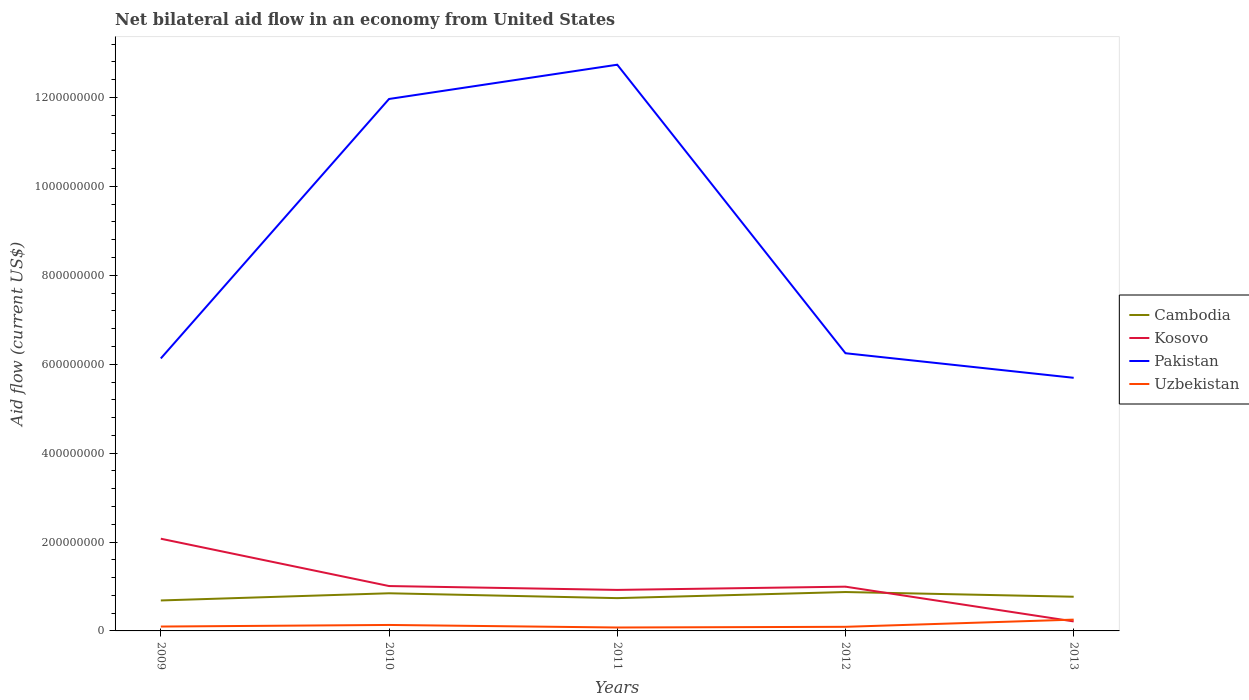Across all years, what is the maximum net bilateral aid flow in Uzbekistan?
Your response must be concise. 7.68e+06. What is the total net bilateral aid flow in Kosovo in the graph?
Make the answer very short. 1.08e+08. What is the difference between the highest and the second highest net bilateral aid flow in Kosovo?
Your answer should be compact. 1.86e+08. Is the net bilateral aid flow in Kosovo strictly greater than the net bilateral aid flow in Pakistan over the years?
Keep it short and to the point. Yes. How many lines are there?
Make the answer very short. 4. How many years are there in the graph?
Provide a short and direct response. 5. What is the difference between two consecutive major ticks on the Y-axis?
Make the answer very short. 2.00e+08. Does the graph contain grids?
Offer a terse response. No. Where does the legend appear in the graph?
Your answer should be compact. Center right. How many legend labels are there?
Make the answer very short. 4. How are the legend labels stacked?
Keep it short and to the point. Vertical. What is the title of the graph?
Ensure brevity in your answer.  Net bilateral aid flow in an economy from United States. What is the label or title of the X-axis?
Provide a short and direct response. Years. What is the Aid flow (current US$) of Cambodia in 2009?
Provide a succinct answer. 6.86e+07. What is the Aid flow (current US$) in Kosovo in 2009?
Ensure brevity in your answer.  2.07e+08. What is the Aid flow (current US$) in Pakistan in 2009?
Keep it short and to the point. 6.13e+08. What is the Aid flow (current US$) in Uzbekistan in 2009?
Provide a succinct answer. 9.85e+06. What is the Aid flow (current US$) in Cambodia in 2010?
Your answer should be compact. 8.47e+07. What is the Aid flow (current US$) of Kosovo in 2010?
Give a very brief answer. 1.01e+08. What is the Aid flow (current US$) of Pakistan in 2010?
Your answer should be very brief. 1.20e+09. What is the Aid flow (current US$) in Uzbekistan in 2010?
Your answer should be very brief. 1.34e+07. What is the Aid flow (current US$) of Cambodia in 2011?
Your answer should be very brief. 7.38e+07. What is the Aid flow (current US$) of Kosovo in 2011?
Your answer should be very brief. 9.23e+07. What is the Aid flow (current US$) in Pakistan in 2011?
Offer a very short reply. 1.27e+09. What is the Aid flow (current US$) in Uzbekistan in 2011?
Your answer should be very brief. 7.68e+06. What is the Aid flow (current US$) of Cambodia in 2012?
Make the answer very short. 8.75e+07. What is the Aid flow (current US$) in Kosovo in 2012?
Offer a very short reply. 9.96e+07. What is the Aid flow (current US$) of Pakistan in 2012?
Offer a very short reply. 6.25e+08. What is the Aid flow (current US$) of Uzbekistan in 2012?
Your response must be concise. 9.25e+06. What is the Aid flow (current US$) of Cambodia in 2013?
Keep it short and to the point. 7.69e+07. What is the Aid flow (current US$) in Kosovo in 2013?
Offer a very short reply. 2.14e+07. What is the Aid flow (current US$) in Pakistan in 2013?
Provide a succinct answer. 5.69e+08. What is the Aid flow (current US$) of Uzbekistan in 2013?
Your response must be concise. 2.54e+07. Across all years, what is the maximum Aid flow (current US$) of Cambodia?
Keep it short and to the point. 8.75e+07. Across all years, what is the maximum Aid flow (current US$) in Kosovo?
Your response must be concise. 2.07e+08. Across all years, what is the maximum Aid flow (current US$) in Pakistan?
Offer a terse response. 1.27e+09. Across all years, what is the maximum Aid flow (current US$) in Uzbekistan?
Keep it short and to the point. 2.54e+07. Across all years, what is the minimum Aid flow (current US$) in Cambodia?
Make the answer very short. 6.86e+07. Across all years, what is the minimum Aid flow (current US$) in Kosovo?
Your answer should be very brief. 2.14e+07. Across all years, what is the minimum Aid flow (current US$) in Pakistan?
Provide a succinct answer. 5.69e+08. Across all years, what is the minimum Aid flow (current US$) in Uzbekistan?
Make the answer very short. 7.68e+06. What is the total Aid flow (current US$) of Cambodia in the graph?
Offer a terse response. 3.91e+08. What is the total Aid flow (current US$) of Kosovo in the graph?
Offer a very short reply. 5.22e+08. What is the total Aid flow (current US$) of Pakistan in the graph?
Your answer should be compact. 4.28e+09. What is the total Aid flow (current US$) of Uzbekistan in the graph?
Your answer should be very brief. 6.56e+07. What is the difference between the Aid flow (current US$) in Cambodia in 2009 and that in 2010?
Offer a terse response. -1.61e+07. What is the difference between the Aid flow (current US$) in Kosovo in 2009 and that in 2010?
Keep it short and to the point. 1.06e+08. What is the difference between the Aid flow (current US$) in Pakistan in 2009 and that in 2010?
Give a very brief answer. -5.84e+08. What is the difference between the Aid flow (current US$) in Uzbekistan in 2009 and that in 2010?
Your response must be concise. -3.59e+06. What is the difference between the Aid flow (current US$) in Cambodia in 2009 and that in 2011?
Offer a terse response. -5.22e+06. What is the difference between the Aid flow (current US$) in Kosovo in 2009 and that in 2011?
Give a very brief answer. 1.15e+08. What is the difference between the Aid flow (current US$) of Pakistan in 2009 and that in 2011?
Give a very brief answer. -6.61e+08. What is the difference between the Aid flow (current US$) of Uzbekistan in 2009 and that in 2011?
Give a very brief answer. 2.17e+06. What is the difference between the Aid flow (current US$) of Cambodia in 2009 and that in 2012?
Offer a terse response. -1.89e+07. What is the difference between the Aid flow (current US$) in Kosovo in 2009 and that in 2012?
Offer a very short reply. 1.08e+08. What is the difference between the Aid flow (current US$) in Pakistan in 2009 and that in 2012?
Your answer should be compact. -1.17e+07. What is the difference between the Aid flow (current US$) in Uzbekistan in 2009 and that in 2012?
Your answer should be compact. 6.00e+05. What is the difference between the Aid flow (current US$) of Cambodia in 2009 and that in 2013?
Your answer should be very brief. -8.36e+06. What is the difference between the Aid flow (current US$) in Kosovo in 2009 and that in 2013?
Your answer should be compact. 1.86e+08. What is the difference between the Aid flow (current US$) in Pakistan in 2009 and that in 2013?
Offer a terse response. 4.36e+07. What is the difference between the Aid flow (current US$) of Uzbekistan in 2009 and that in 2013?
Provide a succinct answer. -1.56e+07. What is the difference between the Aid flow (current US$) in Cambodia in 2010 and that in 2011?
Your answer should be very brief. 1.09e+07. What is the difference between the Aid flow (current US$) in Kosovo in 2010 and that in 2011?
Your answer should be compact. 8.70e+06. What is the difference between the Aid flow (current US$) of Pakistan in 2010 and that in 2011?
Keep it short and to the point. -7.71e+07. What is the difference between the Aid flow (current US$) of Uzbekistan in 2010 and that in 2011?
Provide a succinct answer. 5.76e+06. What is the difference between the Aid flow (current US$) of Cambodia in 2010 and that in 2012?
Your answer should be very brief. -2.78e+06. What is the difference between the Aid flow (current US$) in Kosovo in 2010 and that in 2012?
Keep it short and to the point. 1.42e+06. What is the difference between the Aid flow (current US$) of Pakistan in 2010 and that in 2012?
Your response must be concise. 5.72e+08. What is the difference between the Aid flow (current US$) of Uzbekistan in 2010 and that in 2012?
Your response must be concise. 4.19e+06. What is the difference between the Aid flow (current US$) in Cambodia in 2010 and that in 2013?
Provide a succinct answer. 7.78e+06. What is the difference between the Aid flow (current US$) of Kosovo in 2010 and that in 2013?
Provide a short and direct response. 7.96e+07. What is the difference between the Aid flow (current US$) in Pakistan in 2010 and that in 2013?
Provide a succinct answer. 6.27e+08. What is the difference between the Aid flow (current US$) of Uzbekistan in 2010 and that in 2013?
Offer a very short reply. -1.20e+07. What is the difference between the Aid flow (current US$) in Cambodia in 2011 and that in 2012?
Offer a terse response. -1.37e+07. What is the difference between the Aid flow (current US$) of Kosovo in 2011 and that in 2012?
Your answer should be very brief. -7.28e+06. What is the difference between the Aid flow (current US$) in Pakistan in 2011 and that in 2012?
Make the answer very short. 6.49e+08. What is the difference between the Aid flow (current US$) in Uzbekistan in 2011 and that in 2012?
Your answer should be very brief. -1.57e+06. What is the difference between the Aid flow (current US$) in Cambodia in 2011 and that in 2013?
Offer a terse response. -3.14e+06. What is the difference between the Aid flow (current US$) of Kosovo in 2011 and that in 2013?
Keep it short and to the point. 7.09e+07. What is the difference between the Aid flow (current US$) of Pakistan in 2011 and that in 2013?
Give a very brief answer. 7.04e+08. What is the difference between the Aid flow (current US$) of Uzbekistan in 2011 and that in 2013?
Offer a very short reply. -1.77e+07. What is the difference between the Aid flow (current US$) in Cambodia in 2012 and that in 2013?
Offer a very short reply. 1.06e+07. What is the difference between the Aid flow (current US$) of Kosovo in 2012 and that in 2013?
Your response must be concise. 7.82e+07. What is the difference between the Aid flow (current US$) of Pakistan in 2012 and that in 2013?
Provide a succinct answer. 5.53e+07. What is the difference between the Aid flow (current US$) of Uzbekistan in 2012 and that in 2013?
Give a very brief answer. -1.62e+07. What is the difference between the Aid flow (current US$) in Cambodia in 2009 and the Aid flow (current US$) in Kosovo in 2010?
Your answer should be very brief. -3.24e+07. What is the difference between the Aid flow (current US$) in Cambodia in 2009 and the Aid flow (current US$) in Pakistan in 2010?
Your answer should be very brief. -1.13e+09. What is the difference between the Aid flow (current US$) in Cambodia in 2009 and the Aid flow (current US$) in Uzbekistan in 2010?
Your response must be concise. 5.51e+07. What is the difference between the Aid flow (current US$) of Kosovo in 2009 and the Aid flow (current US$) of Pakistan in 2010?
Keep it short and to the point. -9.89e+08. What is the difference between the Aid flow (current US$) in Kosovo in 2009 and the Aid flow (current US$) in Uzbekistan in 2010?
Offer a terse response. 1.94e+08. What is the difference between the Aid flow (current US$) in Pakistan in 2009 and the Aid flow (current US$) in Uzbekistan in 2010?
Ensure brevity in your answer.  6.00e+08. What is the difference between the Aid flow (current US$) of Cambodia in 2009 and the Aid flow (current US$) of Kosovo in 2011?
Give a very brief answer. -2.37e+07. What is the difference between the Aid flow (current US$) of Cambodia in 2009 and the Aid flow (current US$) of Pakistan in 2011?
Provide a short and direct response. -1.21e+09. What is the difference between the Aid flow (current US$) of Cambodia in 2009 and the Aid flow (current US$) of Uzbekistan in 2011?
Ensure brevity in your answer.  6.09e+07. What is the difference between the Aid flow (current US$) of Kosovo in 2009 and the Aid flow (current US$) of Pakistan in 2011?
Your response must be concise. -1.07e+09. What is the difference between the Aid flow (current US$) in Kosovo in 2009 and the Aid flow (current US$) in Uzbekistan in 2011?
Give a very brief answer. 2.00e+08. What is the difference between the Aid flow (current US$) in Pakistan in 2009 and the Aid flow (current US$) in Uzbekistan in 2011?
Give a very brief answer. 6.05e+08. What is the difference between the Aid flow (current US$) of Cambodia in 2009 and the Aid flow (current US$) of Kosovo in 2012?
Your answer should be very brief. -3.10e+07. What is the difference between the Aid flow (current US$) in Cambodia in 2009 and the Aid flow (current US$) in Pakistan in 2012?
Your answer should be compact. -5.56e+08. What is the difference between the Aid flow (current US$) of Cambodia in 2009 and the Aid flow (current US$) of Uzbekistan in 2012?
Ensure brevity in your answer.  5.93e+07. What is the difference between the Aid flow (current US$) of Kosovo in 2009 and the Aid flow (current US$) of Pakistan in 2012?
Offer a terse response. -4.17e+08. What is the difference between the Aid flow (current US$) of Kosovo in 2009 and the Aid flow (current US$) of Uzbekistan in 2012?
Give a very brief answer. 1.98e+08. What is the difference between the Aid flow (current US$) of Pakistan in 2009 and the Aid flow (current US$) of Uzbekistan in 2012?
Offer a very short reply. 6.04e+08. What is the difference between the Aid flow (current US$) in Cambodia in 2009 and the Aid flow (current US$) in Kosovo in 2013?
Ensure brevity in your answer.  4.72e+07. What is the difference between the Aid flow (current US$) of Cambodia in 2009 and the Aid flow (current US$) of Pakistan in 2013?
Your response must be concise. -5.01e+08. What is the difference between the Aid flow (current US$) of Cambodia in 2009 and the Aid flow (current US$) of Uzbekistan in 2013?
Make the answer very short. 4.31e+07. What is the difference between the Aid flow (current US$) of Kosovo in 2009 and the Aid flow (current US$) of Pakistan in 2013?
Keep it short and to the point. -3.62e+08. What is the difference between the Aid flow (current US$) in Kosovo in 2009 and the Aid flow (current US$) in Uzbekistan in 2013?
Offer a very short reply. 1.82e+08. What is the difference between the Aid flow (current US$) in Pakistan in 2009 and the Aid flow (current US$) in Uzbekistan in 2013?
Your answer should be very brief. 5.88e+08. What is the difference between the Aid flow (current US$) of Cambodia in 2010 and the Aid flow (current US$) of Kosovo in 2011?
Offer a terse response. -7.57e+06. What is the difference between the Aid flow (current US$) in Cambodia in 2010 and the Aid flow (current US$) in Pakistan in 2011?
Keep it short and to the point. -1.19e+09. What is the difference between the Aid flow (current US$) of Cambodia in 2010 and the Aid flow (current US$) of Uzbekistan in 2011?
Your response must be concise. 7.70e+07. What is the difference between the Aid flow (current US$) of Kosovo in 2010 and the Aid flow (current US$) of Pakistan in 2011?
Your response must be concise. -1.17e+09. What is the difference between the Aid flow (current US$) in Kosovo in 2010 and the Aid flow (current US$) in Uzbekistan in 2011?
Make the answer very short. 9.33e+07. What is the difference between the Aid flow (current US$) of Pakistan in 2010 and the Aid flow (current US$) of Uzbekistan in 2011?
Provide a succinct answer. 1.19e+09. What is the difference between the Aid flow (current US$) in Cambodia in 2010 and the Aid flow (current US$) in Kosovo in 2012?
Provide a succinct answer. -1.48e+07. What is the difference between the Aid flow (current US$) in Cambodia in 2010 and the Aid flow (current US$) in Pakistan in 2012?
Keep it short and to the point. -5.40e+08. What is the difference between the Aid flow (current US$) in Cambodia in 2010 and the Aid flow (current US$) in Uzbekistan in 2012?
Offer a terse response. 7.54e+07. What is the difference between the Aid flow (current US$) of Kosovo in 2010 and the Aid flow (current US$) of Pakistan in 2012?
Provide a succinct answer. -5.24e+08. What is the difference between the Aid flow (current US$) of Kosovo in 2010 and the Aid flow (current US$) of Uzbekistan in 2012?
Give a very brief answer. 9.17e+07. What is the difference between the Aid flow (current US$) in Pakistan in 2010 and the Aid flow (current US$) in Uzbekistan in 2012?
Make the answer very short. 1.19e+09. What is the difference between the Aid flow (current US$) of Cambodia in 2010 and the Aid flow (current US$) of Kosovo in 2013?
Make the answer very short. 6.33e+07. What is the difference between the Aid flow (current US$) in Cambodia in 2010 and the Aid flow (current US$) in Pakistan in 2013?
Keep it short and to the point. -4.85e+08. What is the difference between the Aid flow (current US$) in Cambodia in 2010 and the Aid flow (current US$) in Uzbekistan in 2013?
Your answer should be compact. 5.93e+07. What is the difference between the Aid flow (current US$) of Kosovo in 2010 and the Aid flow (current US$) of Pakistan in 2013?
Keep it short and to the point. -4.68e+08. What is the difference between the Aid flow (current US$) of Kosovo in 2010 and the Aid flow (current US$) of Uzbekistan in 2013?
Offer a very short reply. 7.56e+07. What is the difference between the Aid flow (current US$) in Pakistan in 2010 and the Aid flow (current US$) in Uzbekistan in 2013?
Your answer should be compact. 1.17e+09. What is the difference between the Aid flow (current US$) of Cambodia in 2011 and the Aid flow (current US$) of Kosovo in 2012?
Ensure brevity in your answer.  -2.58e+07. What is the difference between the Aid flow (current US$) of Cambodia in 2011 and the Aid flow (current US$) of Pakistan in 2012?
Make the answer very short. -5.51e+08. What is the difference between the Aid flow (current US$) of Cambodia in 2011 and the Aid flow (current US$) of Uzbekistan in 2012?
Your answer should be very brief. 6.45e+07. What is the difference between the Aid flow (current US$) of Kosovo in 2011 and the Aid flow (current US$) of Pakistan in 2012?
Your answer should be compact. -5.32e+08. What is the difference between the Aid flow (current US$) of Kosovo in 2011 and the Aid flow (current US$) of Uzbekistan in 2012?
Provide a succinct answer. 8.30e+07. What is the difference between the Aid flow (current US$) of Pakistan in 2011 and the Aid flow (current US$) of Uzbekistan in 2012?
Your answer should be compact. 1.26e+09. What is the difference between the Aid flow (current US$) in Cambodia in 2011 and the Aid flow (current US$) in Kosovo in 2013?
Provide a short and direct response. 5.24e+07. What is the difference between the Aid flow (current US$) in Cambodia in 2011 and the Aid flow (current US$) in Pakistan in 2013?
Your response must be concise. -4.96e+08. What is the difference between the Aid flow (current US$) in Cambodia in 2011 and the Aid flow (current US$) in Uzbekistan in 2013?
Offer a very short reply. 4.84e+07. What is the difference between the Aid flow (current US$) in Kosovo in 2011 and the Aid flow (current US$) in Pakistan in 2013?
Your response must be concise. -4.77e+08. What is the difference between the Aid flow (current US$) in Kosovo in 2011 and the Aid flow (current US$) in Uzbekistan in 2013?
Your answer should be very brief. 6.68e+07. What is the difference between the Aid flow (current US$) of Pakistan in 2011 and the Aid flow (current US$) of Uzbekistan in 2013?
Make the answer very short. 1.25e+09. What is the difference between the Aid flow (current US$) of Cambodia in 2012 and the Aid flow (current US$) of Kosovo in 2013?
Ensure brevity in your answer.  6.61e+07. What is the difference between the Aid flow (current US$) of Cambodia in 2012 and the Aid flow (current US$) of Pakistan in 2013?
Your response must be concise. -4.82e+08. What is the difference between the Aid flow (current US$) in Cambodia in 2012 and the Aid flow (current US$) in Uzbekistan in 2013?
Keep it short and to the point. 6.21e+07. What is the difference between the Aid flow (current US$) of Kosovo in 2012 and the Aid flow (current US$) of Pakistan in 2013?
Keep it short and to the point. -4.70e+08. What is the difference between the Aid flow (current US$) in Kosovo in 2012 and the Aid flow (current US$) in Uzbekistan in 2013?
Make the answer very short. 7.41e+07. What is the difference between the Aid flow (current US$) of Pakistan in 2012 and the Aid flow (current US$) of Uzbekistan in 2013?
Ensure brevity in your answer.  5.99e+08. What is the average Aid flow (current US$) of Cambodia per year?
Your answer should be very brief. 7.83e+07. What is the average Aid flow (current US$) in Kosovo per year?
Provide a short and direct response. 1.04e+08. What is the average Aid flow (current US$) in Pakistan per year?
Offer a very short reply. 8.56e+08. What is the average Aid flow (current US$) in Uzbekistan per year?
Make the answer very short. 1.31e+07. In the year 2009, what is the difference between the Aid flow (current US$) in Cambodia and Aid flow (current US$) in Kosovo?
Your answer should be very brief. -1.39e+08. In the year 2009, what is the difference between the Aid flow (current US$) of Cambodia and Aid flow (current US$) of Pakistan?
Keep it short and to the point. -5.44e+08. In the year 2009, what is the difference between the Aid flow (current US$) of Cambodia and Aid flow (current US$) of Uzbekistan?
Your response must be concise. 5.87e+07. In the year 2009, what is the difference between the Aid flow (current US$) in Kosovo and Aid flow (current US$) in Pakistan?
Offer a very short reply. -4.06e+08. In the year 2009, what is the difference between the Aid flow (current US$) of Kosovo and Aid flow (current US$) of Uzbekistan?
Offer a very short reply. 1.98e+08. In the year 2009, what is the difference between the Aid flow (current US$) of Pakistan and Aid flow (current US$) of Uzbekistan?
Keep it short and to the point. 6.03e+08. In the year 2010, what is the difference between the Aid flow (current US$) in Cambodia and Aid flow (current US$) in Kosovo?
Give a very brief answer. -1.63e+07. In the year 2010, what is the difference between the Aid flow (current US$) in Cambodia and Aid flow (current US$) in Pakistan?
Provide a succinct answer. -1.11e+09. In the year 2010, what is the difference between the Aid flow (current US$) in Cambodia and Aid flow (current US$) in Uzbekistan?
Keep it short and to the point. 7.13e+07. In the year 2010, what is the difference between the Aid flow (current US$) in Kosovo and Aid flow (current US$) in Pakistan?
Provide a succinct answer. -1.10e+09. In the year 2010, what is the difference between the Aid flow (current US$) in Kosovo and Aid flow (current US$) in Uzbekistan?
Ensure brevity in your answer.  8.75e+07. In the year 2010, what is the difference between the Aid flow (current US$) of Pakistan and Aid flow (current US$) of Uzbekistan?
Offer a very short reply. 1.18e+09. In the year 2011, what is the difference between the Aid flow (current US$) of Cambodia and Aid flow (current US$) of Kosovo?
Offer a very short reply. -1.85e+07. In the year 2011, what is the difference between the Aid flow (current US$) in Cambodia and Aid flow (current US$) in Pakistan?
Your answer should be compact. -1.20e+09. In the year 2011, what is the difference between the Aid flow (current US$) of Cambodia and Aid flow (current US$) of Uzbekistan?
Your response must be concise. 6.61e+07. In the year 2011, what is the difference between the Aid flow (current US$) of Kosovo and Aid flow (current US$) of Pakistan?
Your answer should be compact. -1.18e+09. In the year 2011, what is the difference between the Aid flow (current US$) in Kosovo and Aid flow (current US$) in Uzbekistan?
Keep it short and to the point. 8.46e+07. In the year 2011, what is the difference between the Aid flow (current US$) of Pakistan and Aid flow (current US$) of Uzbekistan?
Keep it short and to the point. 1.27e+09. In the year 2012, what is the difference between the Aid flow (current US$) of Cambodia and Aid flow (current US$) of Kosovo?
Give a very brief answer. -1.21e+07. In the year 2012, what is the difference between the Aid flow (current US$) of Cambodia and Aid flow (current US$) of Pakistan?
Give a very brief answer. -5.37e+08. In the year 2012, what is the difference between the Aid flow (current US$) of Cambodia and Aid flow (current US$) of Uzbekistan?
Your response must be concise. 7.82e+07. In the year 2012, what is the difference between the Aid flow (current US$) of Kosovo and Aid flow (current US$) of Pakistan?
Your answer should be very brief. -5.25e+08. In the year 2012, what is the difference between the Aid flow (current US$) of Kosovo and Aid flow (current US$) of Uzbekistan?
Your answer should be compact. 9.03e+07. In the year 2012, what is the difference between the Aid flow (current US$) in Pakistan and Aid flow (current US$) in Uzbekistan?
Offer a terse response. 6.16e+08. In the year 2013, what is the difference between the Aid flow (current US$) in Cambodia and Aid flow (current US$) in Kosovo?
Give a very brief answer. 5.55e+07. In the year 2013, what is the difference between the Aid flow (current US$) of Cambodia and Aid flow (current US$) of Pakistan?
Keep it short and to the point. -4.93e+08. In the year 2013, what is the difference between the Aid flow (current US$) of Cambodia and Aid flow (current US$) of Uzbekistan?
Provide a succinct answer. 5.15e+07. In the year 2013, what is the difference between the Aid flow (current US$) of Kosovo and Aid flow (current US$) of Pakistan?
Your response must be concise. -5.48e+08. In the year 2013, what is the difference between the Aid flow (current US$) in Kosovo and Aid flow (current US$) in Uzbekistan?
Your answer should be compact. -4.03e+06. In the year 2013, what is the difference between the Aid flow (current US$) in Pakistan and Aid flow (current US$) in Uzbekistan?
Provide a succinct answer. 5.44e+08. What is the ratio of the Aid flow (current US$) in Cambodia in 2009 to that in 2010?
Your answer should be compact. 0.81. What is the ratio of the Aid flow (current US$) of Kosovo in 2009 to that in 2010?
Make the answer very short. 2.05. What is the ratio of the Aid flow (current US$) in Pakistan in 2009 to that in 2010?
Provide a short and direct response. 0.51. What is the ratio of the Aid flow (current US$) in Uzbekistan in 2009 to that in 2010?
Your response must be concise. 0.73. What is the ratio of the Aid flow (current US$) in Cambodia in 2009 to that in 2011?
Offer a very short reply. 0.93. What is the ratio of the Aid flow (current US$) of Kosovo in 2009 to that in 2011?
Offer a terse response. 2.25. What is the ratio of the Aid flow (current US$) of Pakistan in 2009 to that in 2011?
Keep it short and to the point. 0.48. What is the ratio of the Aid flow (current US$) of Uzbekistan in 2009 to that in 2011?
Your response must be concise. 1.28. What is the ratio of the Aid flow (current US$) in Cambodia in 2009 to that in 2012?
Your response must be concise. 0.78. What is the ratio of the Aid flow (current US$) in Kosovo in 2009 to that in 2012?
Make the answer very short. 2.08. What is the ratio of the Aid flow (current US$) in Pakistan in 2009 to that in 2012?
Offer a very short reply. 0.98. What is the ratio of the Aid flow (current US$) of Uzbekistan in 2009 to that in 2012?
Keep it short and to the point. 1.06. What is the ratio of the Aid flow (current US$) of Cambodia in 2009 to that in 2013?
Your answer should be compact. 0.89. What is the ratio of the Aid flow (current US$) of Kosovo in 2009 to that in 2013?
Offer a very short reply. 9.7. What is the ratio of the Aid flow (current US$) in Pakistan in 2009 to that in 2013?
Provide a succinct answer. 1.08. What is the ratio of the Aid flow (current US$) of Uzbekistan in 2009 to that in 2013?
Offer a terse response. 0.39. What is the ratio of the Aid flow (current US$) in Cambodia in 2010 to that in 2011?
Provide a short and direct response. 1.15. What is the ratio of the Aid flow (current US$) in Kosovo in 2010 to that in 2011?
Make the answer very short. 1.09. What is the ratio of the Aid flow (current US$) in Pakistan in 2010 to that in 2011?
Your answer should be very brief. 0.94. What is the ratio of the Aid flow (current US$) in Uzbekistan in 2010 to that in 2011?
Offer a very short reply. 1.75. What is the ratio of the Aid flow (current US$) in Cambodia in 2010 to that in 2012?
Provide a succinct answer. 0.97. What is the ratio of the Aid flow (current US$) of Kosovo in 2010 to that in 2012?
Make the answer very short. 1.01. What is the ratio of the Aid flow (current US$) of Pakistan in 2010 to that in 2012?
Keep it short and to the point. 1.92. What is the ratio of the Aid flow (current US$) of Uzbekistan in 2010 to that in 2012?
Offer a terse response. 1.45. What is the ratio of the Aid flow (current US$) of Cambodia in 2010 to that in 2013?
Offer a terse response. 1.1. What is the ratio of the Aid flow (current US$) in Kosovo in 2010 to that in 2013?
Make the answer very short. 4.72. What is the ratio of the Aid flow (current US$) of Pakistan in 2010 to that in 2013?
Give a very brief answer. 2.1. What is the ratio of the Aid flow (current US$) in Uzbekistan in 2010 to that in 2013?
Offer a terse response. 0.53. What is the ratio of the Aid flow (current US$) of Cambodia in 2011 to that in 2012?
Make the answer very short. 0.84. What is the ratio of the Aid flow (current US$) in Kosovo in 2011 to that in 2012?
Provide a short and direct response. 0.93. What is the ratio of the Aid flow (current US$) of Pakistan in 2011 to that in 2012?
Ensure brevity in your answer.  2.04. What is the ratio of the Aid flow (current US$) in Uzbekistan in 2011 to that in 2012?
Keep it short and to the point. 0.83. What is the ratio of the Aid flow (current US$) of Cambodia in 2011 to that in 2013?
Your answer should be compact. 0.96. What is the ratio of the Aid flow (current US$) of Kosovo in 2011 to that in 2013?
Keep it short and to the point. 4.31. What is the ratio of the Aid flow (current US$) in Pakistan in 2011 to that in 2013?
Offer a very short reply. 2.24. What is the ratio of the Aid flow (current US$) of Uzbekistan in 2011 to that in 2013?
Provide a succinct answer. 0.3. What is the ratio of the Aid flow (current US$) in Cambodia in 2012 to that in 2013?
Offer a terse response. 1.14. What is the ratio of the Aid flow (current US$) of Kosovo in 2012 to that in 2013?
Provide a short and direct response. 4.65. What is the ratio of the Aid flow (current US$) in Pakistan in 2012 to that in 2013?
Provide a succinct answer. 1.1. What is the ratio of the Aid flow (current US$) of Uzbekistan in 2012 to that in 2013?
Offer a very short reply. 0.36. What is the difference between the highest and the second highest Aid flow (current US$) of Cambodia?
Your response must be concise. 2.78e+06. What is the difference between the highest and the second highest Aid flow (current US$) in Kosovo?
Make the answer very short. 1.06e+08. What is the difference between the highest and the second highest Aid flow (current US$) in Pakistan?
Your response must be concise. 7.71e+07. What is the difference between the highest and the second highest Aid flow (current US$) in Uzbekistan?
Keep it short and to the point. 1.20e+07. What is the difference between the highest and the lowest Aid flow (current US$) in Cambodia?
Keep it short and to the point. 1.89e+07. What is the difference between the highest and the lowest Aid flow (current US$) in Kosovo?
Your answer should be very brief. 1.86e+08. What is the difference between the highest and the lowest Aid flow (current US$) in Pakistan?
Make the answer very short. 7.04e+08. What is the difference between the highest and the lowest Aid flow (current US$) in Uzbekistan?
Your answer should be very brief. 1.77e+07. 